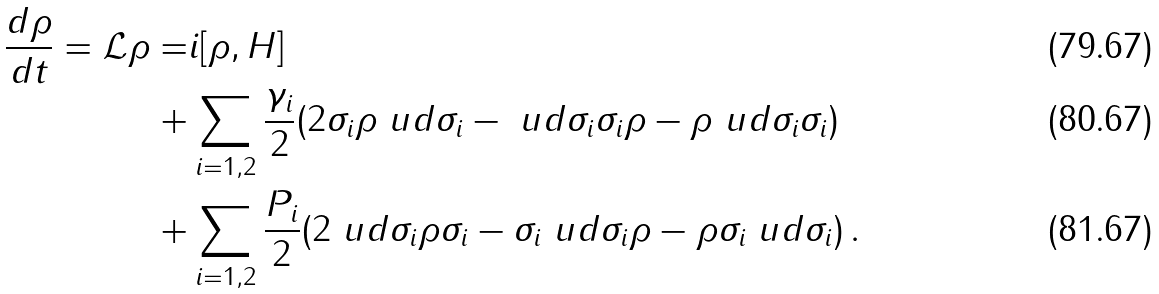Convert formula to latex. <formula><loc_0><loc_0><loc_500><loc_500>\frac { d \rho } { d t } = \mathcal { L } \rho = & i [ \rho , H ] \\ + & \sum _ { i = 1 , 2 } \frac { \gamma _ { i } } { 2 } ( 2 \sigma _ { i } \rho \ u d { \sigma } _ { i } - \ u d { \sigma } _ { i } \sigma _ { i } \rho - \rho \ u d { \sigma } _ { i } \sigma _ { i } ) \\ + & \sum _ { i = 1 , 2 } \frac { P _ { i } } { 2 } ( 2 \ u d { \sigma } _ { i } \rho \sigma _ { i } - \sigma _ { i } \ u d { \sigma } _ { i } \rho - \rho \sigma _ { i } \ u d { \sigma } _ { i } ) \, .</formula> 